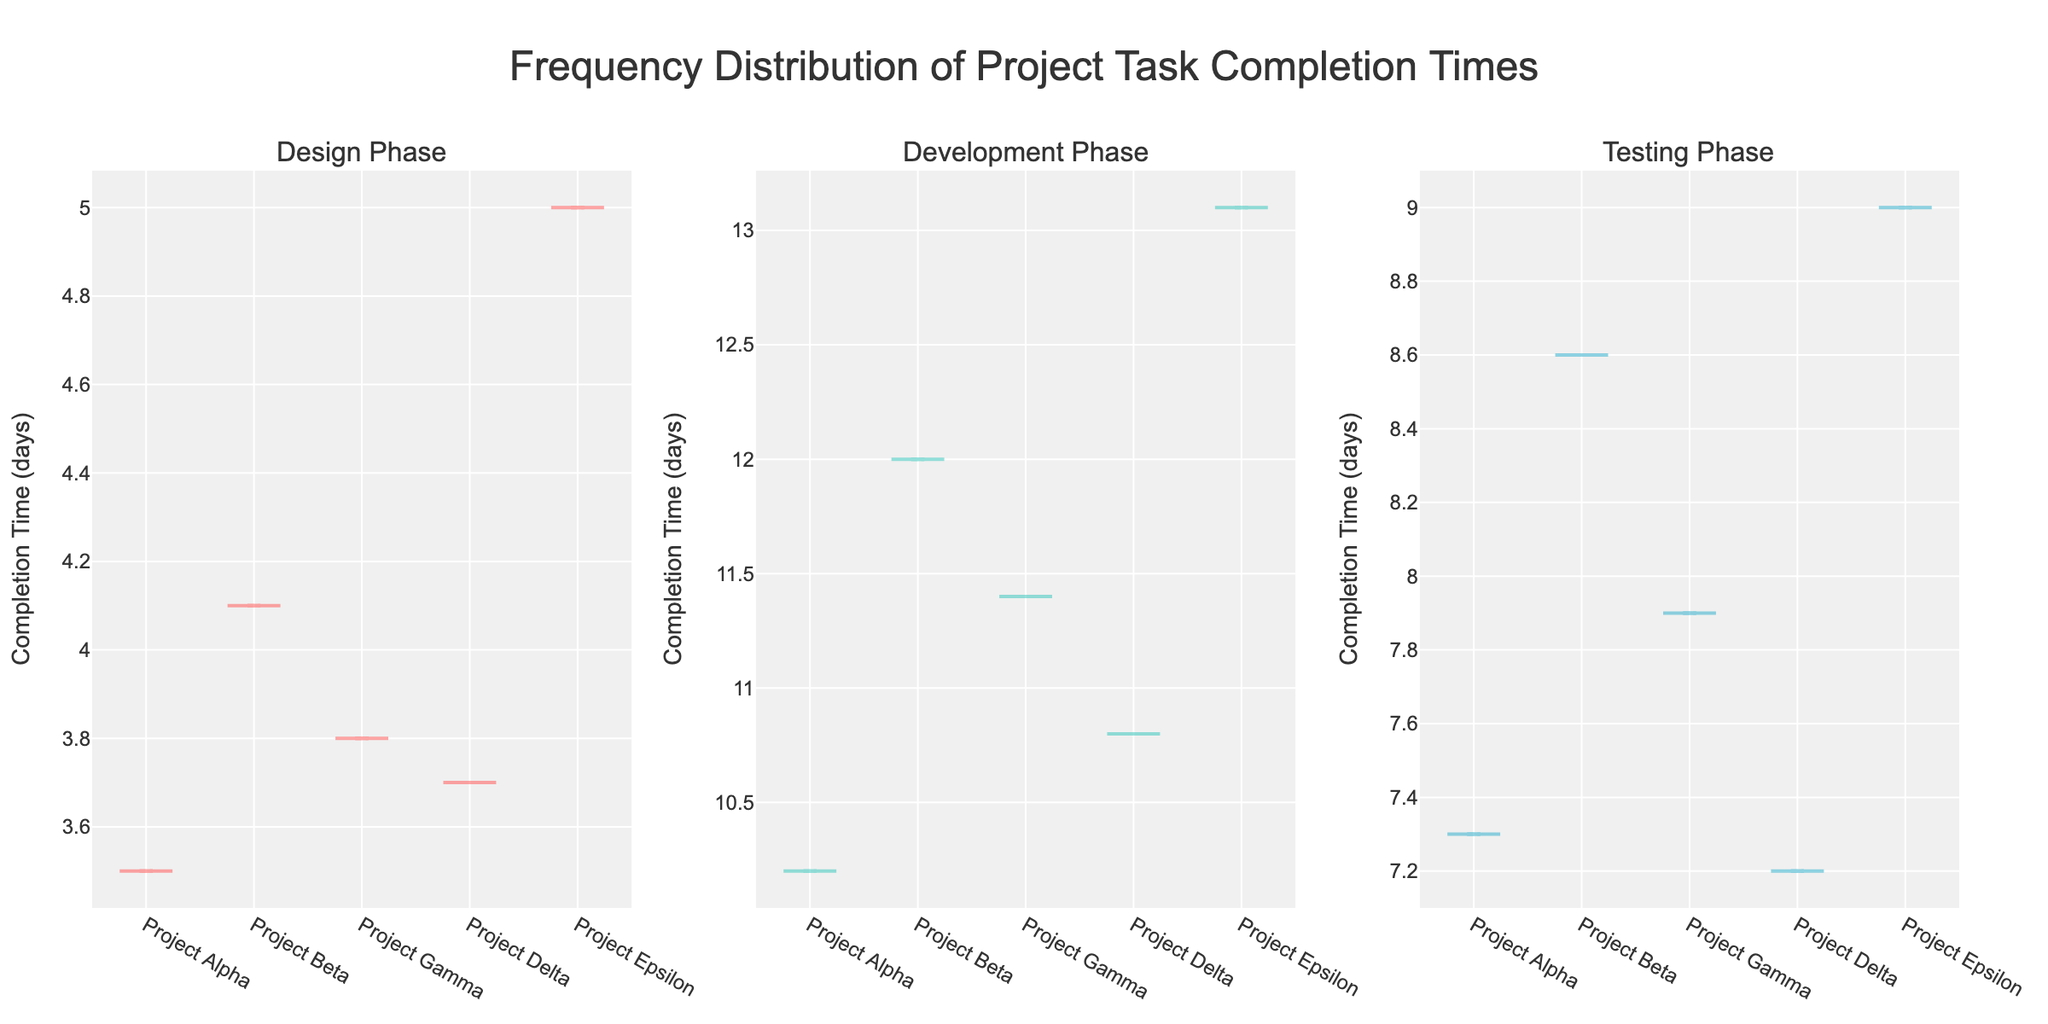Which phases are shown in the subplots? The subplots show data for three distinct phases of the project tasks. The phases shown in the subplots are labeled as "Design Phase," "Development Phase," and "Testing Phase."
Answer: Design Phase, Development Phase, Testing Phase What is the title of the figure? The figure has a central title at the top of the subplots. The title of the figure is "Frequency Distribution of Project Task Completion Times."
Answer: Frequency Distribution of Project Task Completion Times Which project has the shortest completion time in the Design Phase? By looking at the individual violins within the "Design Phase" subplot, the shortest completion time among the projects can be identified. The shortest completion time is 3.5 days, which corresponds to "Project Alpha."
Answer: Project Alpha In the Development Phase, which project has the longest completion time? The "Development Phase" subplot illustrates the distribution of completion times for each project. By examining this subplot, the longest completion time of 13.1 days belongs to "Project Epsilon."
Answer: Project Epsilon What is the range of completion times in the Testing Phase across all projects? To find the range, identify the minimum and maximum completion times in the "Testing Phase" subplot. The minimum completion time is 7.2 days (Project Delta), and the maximum is 9.0 days (Project Epsilon). The range is the difference between these values.
Answer: 1.8 days Compare the mean completion times for the Design Phase and Testing Phase. Which phase has a higher mean completion time? The mean lines within each violin can be compared to find the average completion time for each phase. The "Design Phase" has a lower mean completion time compared to the "Testing Phase," where the means are slightly higher.
Answer: Testing Phase Does any project appear in more than one phase plot? If so, name them. By examining each subplot, it is confirmed that each project appears in all three phase plots. Therefore, all projects appear in more than one phase plot.
Answer: All projects: Project Alpha, Project Beta, Project Gamma, Project Delta, Project Epsilon Which phase exhibits the most variability in task completion times? The distribution within each violin (width and spread) indicates variability. The "Development Phase" subplot shows the most spread out and wide distribution, indicating the highest variability.
Answer: Development Phase Is there an outlier in any of the project completion times in the Development Phase? Outliers often appear distinctly outside the main body of the violin. In the "Development Phase" subplot, there does not appear to be a significant outlier; the distributions are more continuous.
Answer: No outlier How do the completion times of Project Gamma compare across the three different phases? By checking the position of Project Gamma in all three subplots, it can be seen that in the "Design Phase" Project Gamma has a time close to average, in the "Development Phase" it is slightly above average, and in the "Testing Phase" it is near the upper end but not the maximum.
Answer: Consistent: slightly above average in Development, near average in other phases 